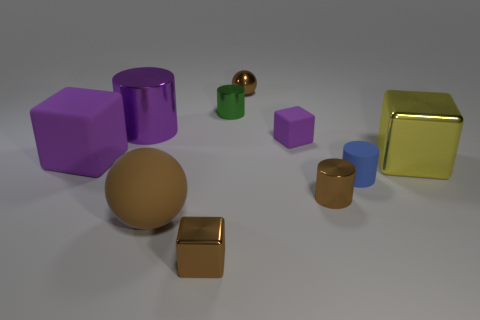Is the number of purple shiny things greater than the number of tiny brown objects?
Offer a terse response. No. Is the small ball the same color as the tiny rubber cylinder?
Ensure brevity in your answer.  No. What number of objects are either yellow blocks or objects on the right side of the blue matte cylinder?
Ensure brevity in your answer.  1. What number of other things are there of the same shape as the green metallic object?
Keep it short and to the point. 3. Are there fewer purple shiny things that are on the right side of the small green shiny thing than small cubes behind the large metal cylinder?
Keep it short and to the point. No. Are there any other things that are the same material as the tiny blue cylinder?
Keep it short and to the point. Yes. What is the shape of the large brown object that is made of the same material as the tiny blue cylinder?
Offer a terse response. Sphere. Is there anything else of the same color as the large cylinder?
Provide a succinct answer. Yes. The metal cylinder that is right of the small brown metal object behind the big metallic cube is what color?
Your answer should be compact. Brown. There is a large block left of the large thing in front of the large yellow cube that is on the right side of the blue rubber thing; what is its material?
Offer a terse response. Rubber. 